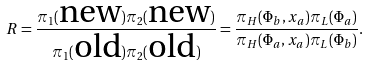Convert formula to latex. <formula><loc_0><loc_0><loc_500><loc_500>R = \frac { \pi _ { 1 } ( \text {new} ) \pi _ { 2 } ( \text {new} ) } { \pi _ { 1 } ( \text {old} ) \pi _ { 2 } ( \text {old} ) } = \frac { \pi _ { H } ( \Phi _ { b } , x _ { a } ) \pi _ { L } ( \Phi _ { a } ) } { \pi _ { H } ( \Phi _ { a } , x _ { a } ) \pi _ { L } ( \Phi _ { b } ) } .</formula> 